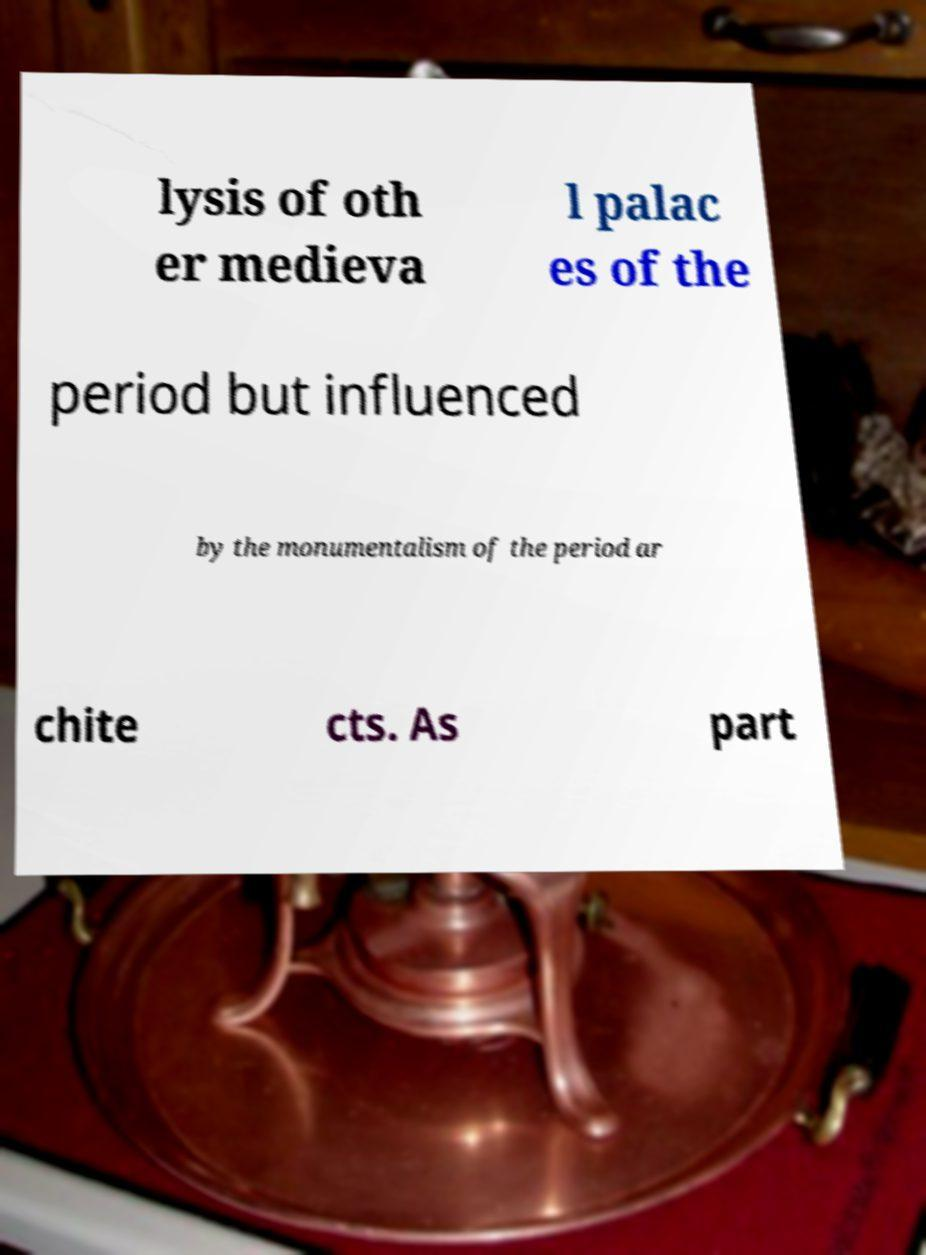There's text embedded in this image that I need extracted. Can you transcribe it verbatim? lysis of oth er medieva l palac es of the period but influenced by the monumentalism of the period ar chite cts. As part 